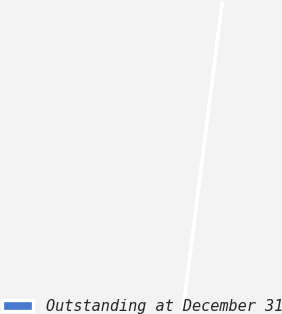<chart> <loc_0><loc_0><loc_500><loc_500><pie_chart><fcel>Outstanding at December 31<nl><fcel>100.0%<nl></chart> 